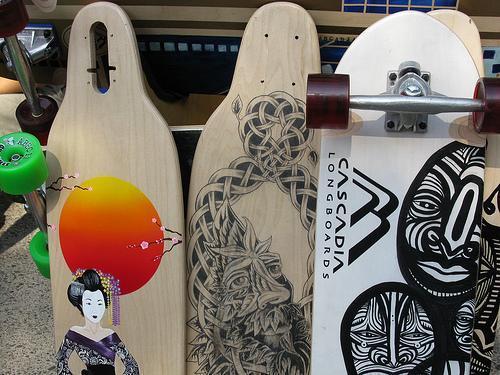How many skateboards have wheels?
Give a very brief answer. 1. How many boards are shown?
Give a very brief answer. 4. How many boards are visible?
Give a very brief answer. 6. 